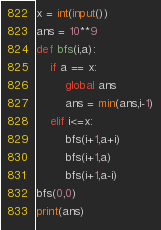Convert code to text. <code><loc_0><loc_0><loc_500><loc_500><_Python_>x = int(input())
ans = 10**9
def bfs(i,a):
    if a == x:
        global ans
        ans = min(ans,i-1)
    elif i<=x:
        bfs(i+1,a+i)
        bfs(i+1,a)
        bfs(i+1,a-i)
bfs(0,0)
print(ans)</code> 